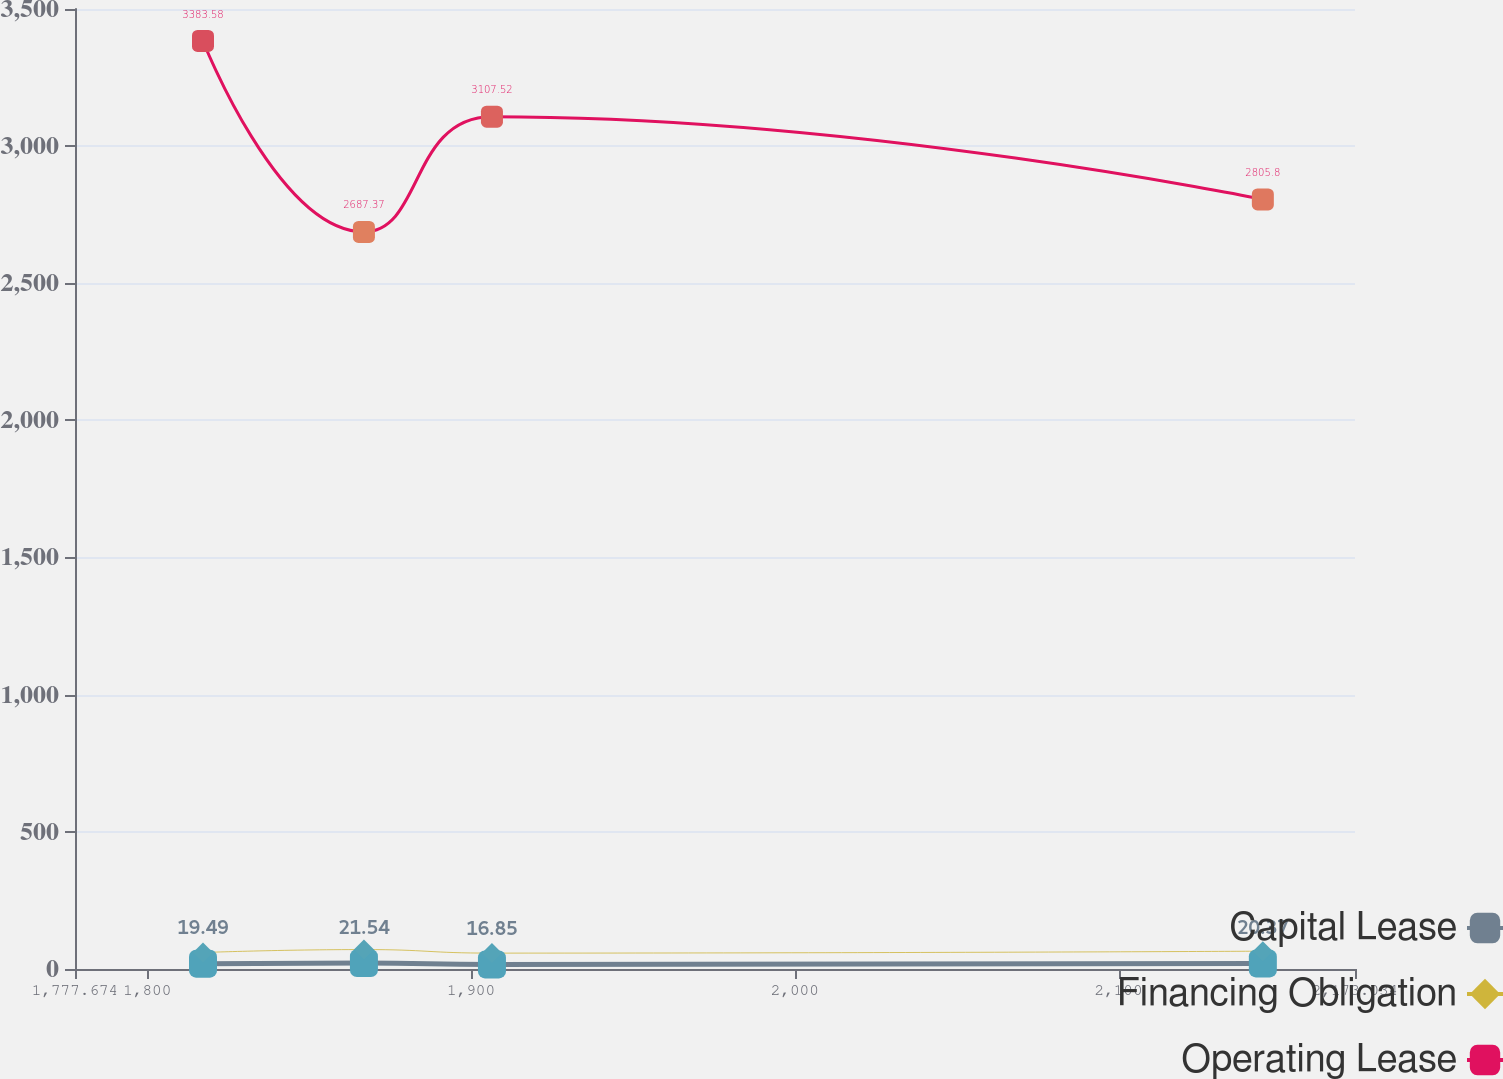Convert chart to OTSL. <chart><loc_0><loc_0><loc_500><loc_500><line_chart><ecel><fcel>Capital Lease<fcel>Financing Obligation<fcel>Operating Lease<nl><fcel>1817.21<fcel>19.49<fcel>60.08<fcel>3383.58<nl><fcel>1866.92<fcel>21.54<fcel>70.87<fcel>2687.37<nl><fcel>1906.46<fcel>16.85<fcel>57.92<fcel>3107.52<nl><fcel>2144.57<fcel>20.37<fcel>64.97<fcel>2805.8<nl><fcel>2212.57<fcel>20.9<fcel>68<fcel>2199.24<nl></chart> 